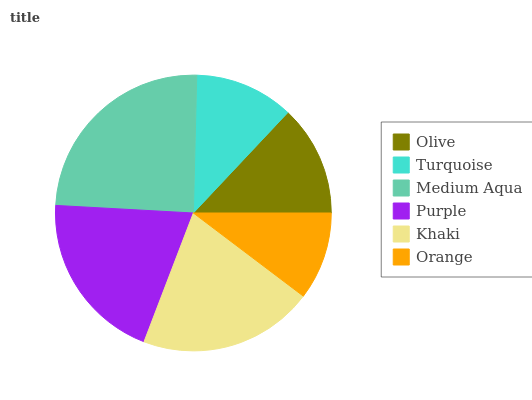Is Orange the minimum?
Answer yes or no. Yes. Is Medium Aqua the maximum?
Answer yes or no. Yes. Is Turquoise the minimum?
Answer yes or no. No. Is Turquoise the maximum?
Answer yes or no. No. Is Olive greater than Turquoise?
Answer yes or no. Yes. Is Turquoise less than Olive?
Answer yes or no. Yes. Is Turquoise greater than Olive?
Answer yes or no. No. Is Olive less than Turquoise?
Answer yes or no. No. Is Purple the high median?
Answer yes or no. Yes. Is Olive the low median?
Answer yes or no. Yes. Is Turquoise the high median?
Answer yes or no. No. Is Turquoise the low median?
Answer yes or no. No. 